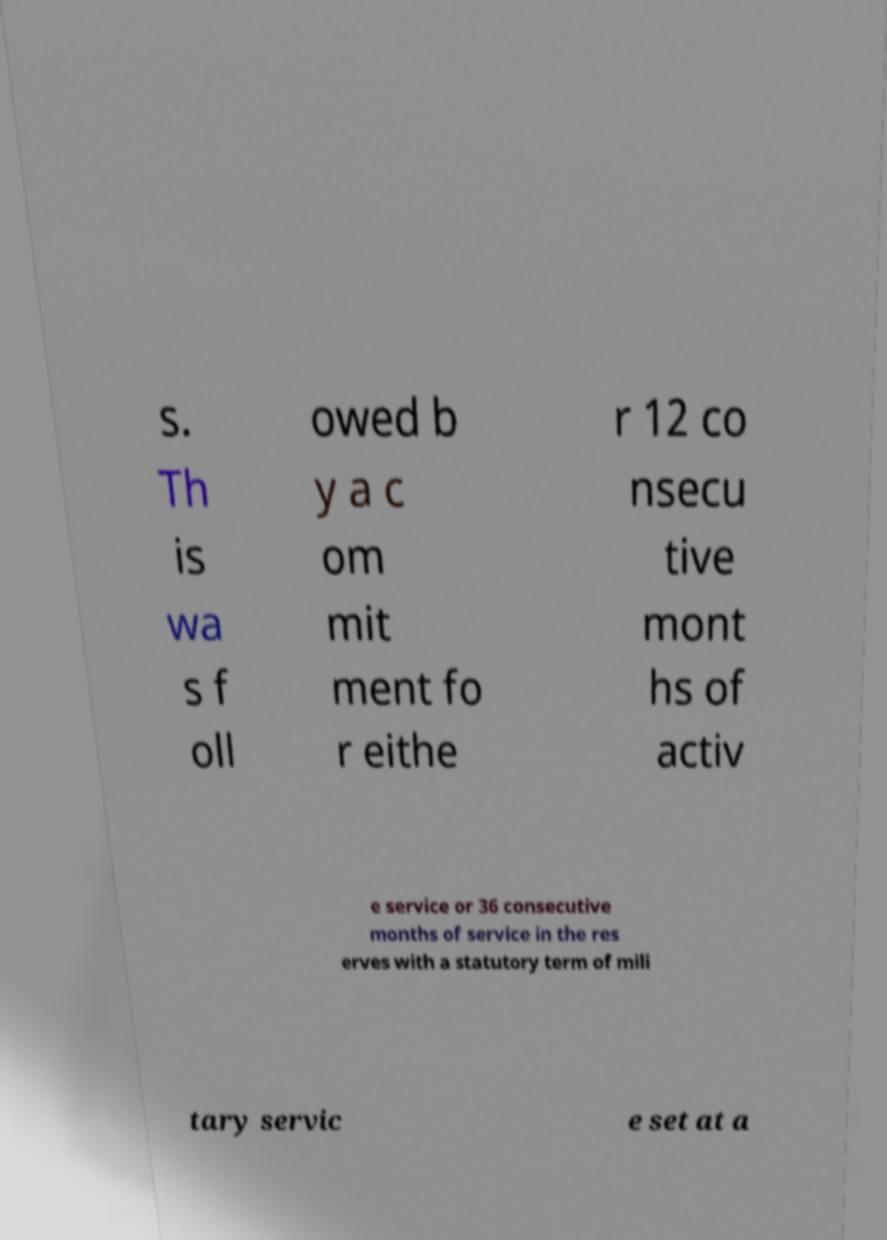Could you extract and type out the text from this image? s. Th is wa s f oll owed b y a c om mit ment fo r eithe r 12 co nsecu tive mont hs of activ e service or 36 consecutive months of service in the res erves with a statutory term of mili tary servic e set at a 